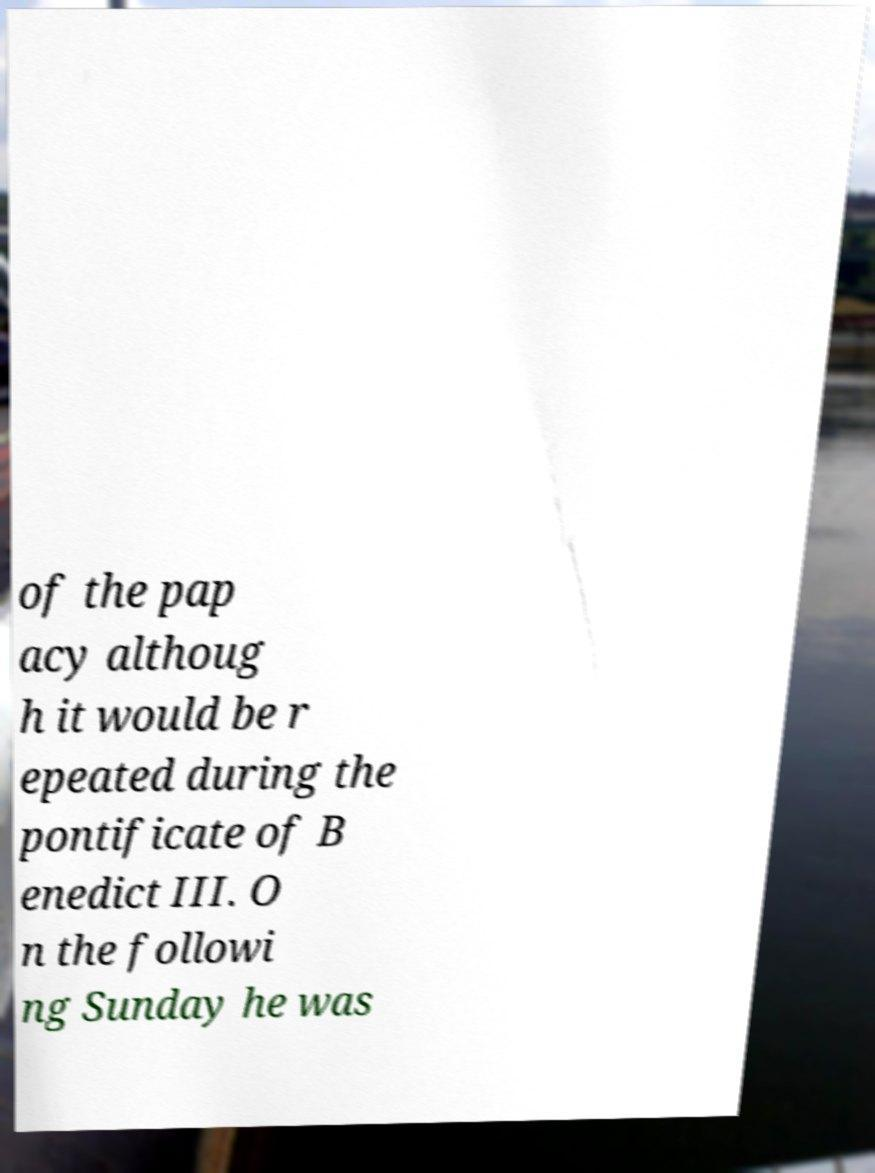Please identify and transcribe the text found in this image. of the pap acy althoug h it would be r epeated during the pontificate of B enedict III. O n the followi ng Sunday he was 